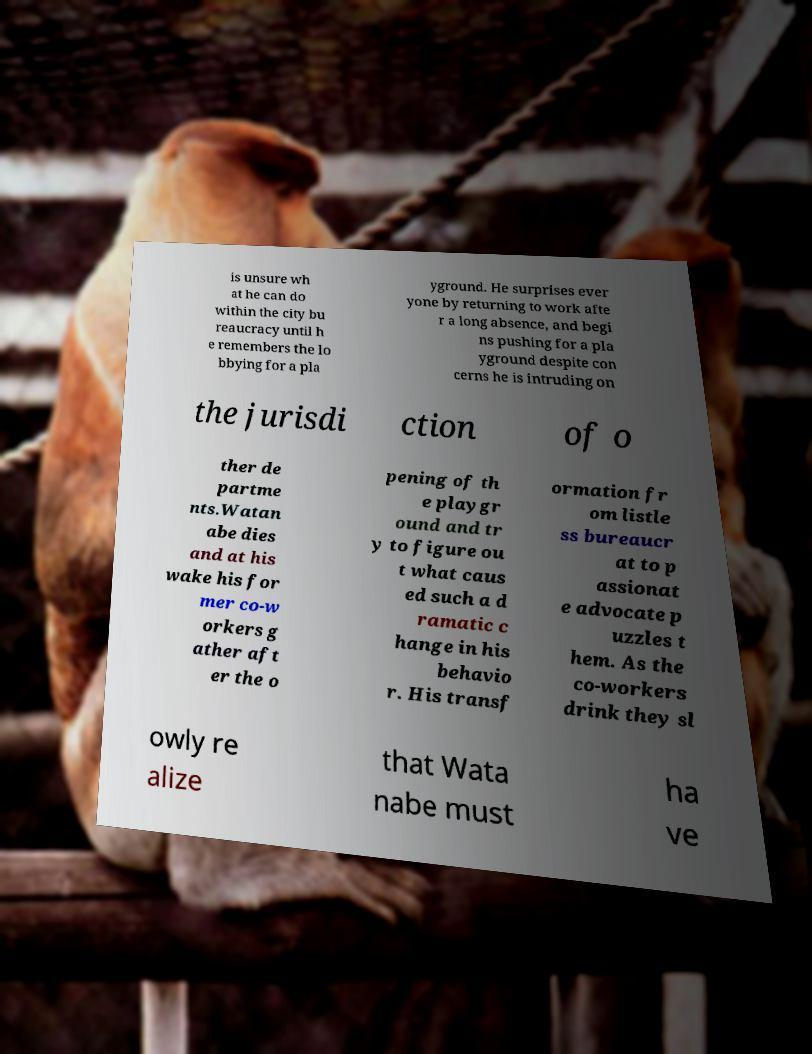Could you extract and type out the text from this image? is unsure wh at he can do within the city bu reaucracy until h e remembers the lo bbying for a pla yground. He surprises ever yone by returning to work afte r a long absence, and begi ns pushing for a pla yground despite con cerns he is intruding on the jurisdi ction of o ther de partme nts.Watan abe dies and at his wake his for mer co-w orkers g ather aft er the o pening of th e playgr ound and tr y to figure ou t what caus ed such a d ramatic c hange in his behavio r. His transf ormation fr om listle ss bureaucr at to p assionat e advocate p uzzles t hem. As the co-workers drink they sl owly re alize that Wata nabe must ha ve 